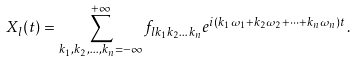Convert formula to latex. <formula><loc_0><loc_0><loc_500><loc_500>X _ { l } ( t ) = \sum _ { k _ { 1 } , k _ { 2 } , \dots , k _ { n } = - \infty } ^ { + \infty } f _ { l k _ { 1 } k _ { 2 } \dots k _ { n } } e ^ { i ( k _ { 1 } \omega _ { 1 } + k _ { 2 } \omega _ { 2 } + \dots + k _ { n } \omega _ { n } ) t } \, .</formula> 